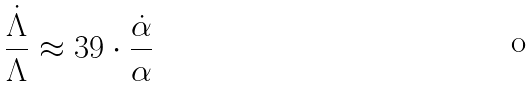Convert formula to latex. <formula><loc_0><loc_0><loc_500><loc_500>\frac { \dot { \Lambda } } { \Lambda } \approx 3 9 \cdot \frac { \dot { \alpha } } { \alpha }</formula> 